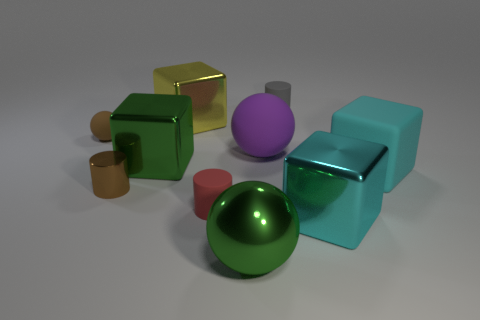Is the brown rubber object the same shape as the large purple rubber object?
Ensure brevity in your answer.  Yes. Is the size of the cyan matte thing the same as the green shiny sphere?
Offer a very short reply. Yes. Are there any rubber spheres of the same color as the tiny shiny cylinder?
Make the answer very short. Yes. Is the shape of the big matte thing that is on the left side of the big cyan metal object the same as  the small brown shiny thing?
Your response must be concise. No. How many brown rubber spheres are the same size as the cyan rubber object?
Make the answer very short. 0. There is a big cube that is behind the green metal cube; what number of big green shiny cubes are in front of it?
Your response must be concise. 1. Do the ball in front of the large cyan matte thing and the small gray object have the same material?
Your answer should be very brief. No. Are the green thing behind the small red rubber thing and the ball right of the metallic sphere made of the same material?
Offer a terse response. No. Are there more large yellow blocks on the right side of the yellow metal cube than gray matte objects?
Your response must be concise. No. There is a big rubber object left of the block that is in front of the brown metallic object; what is its color?
Give a very brief answer. Purple. 